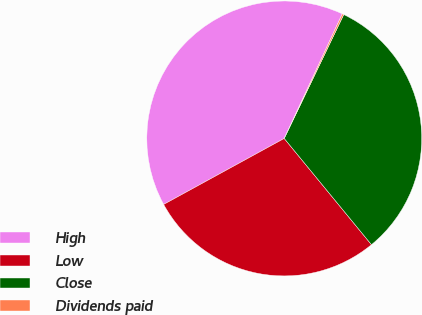Convert chart to OTSL. <chart><loc_0><loc_0><loc_500><loc_500><pie_chart><fcel>High<fcel>Low<fcel>Close<fcel>Dividends paid<nl><fcel>39.91%<fcel>27.97%<fcel>31.93%<fcel>0.19%<nl></chart> 